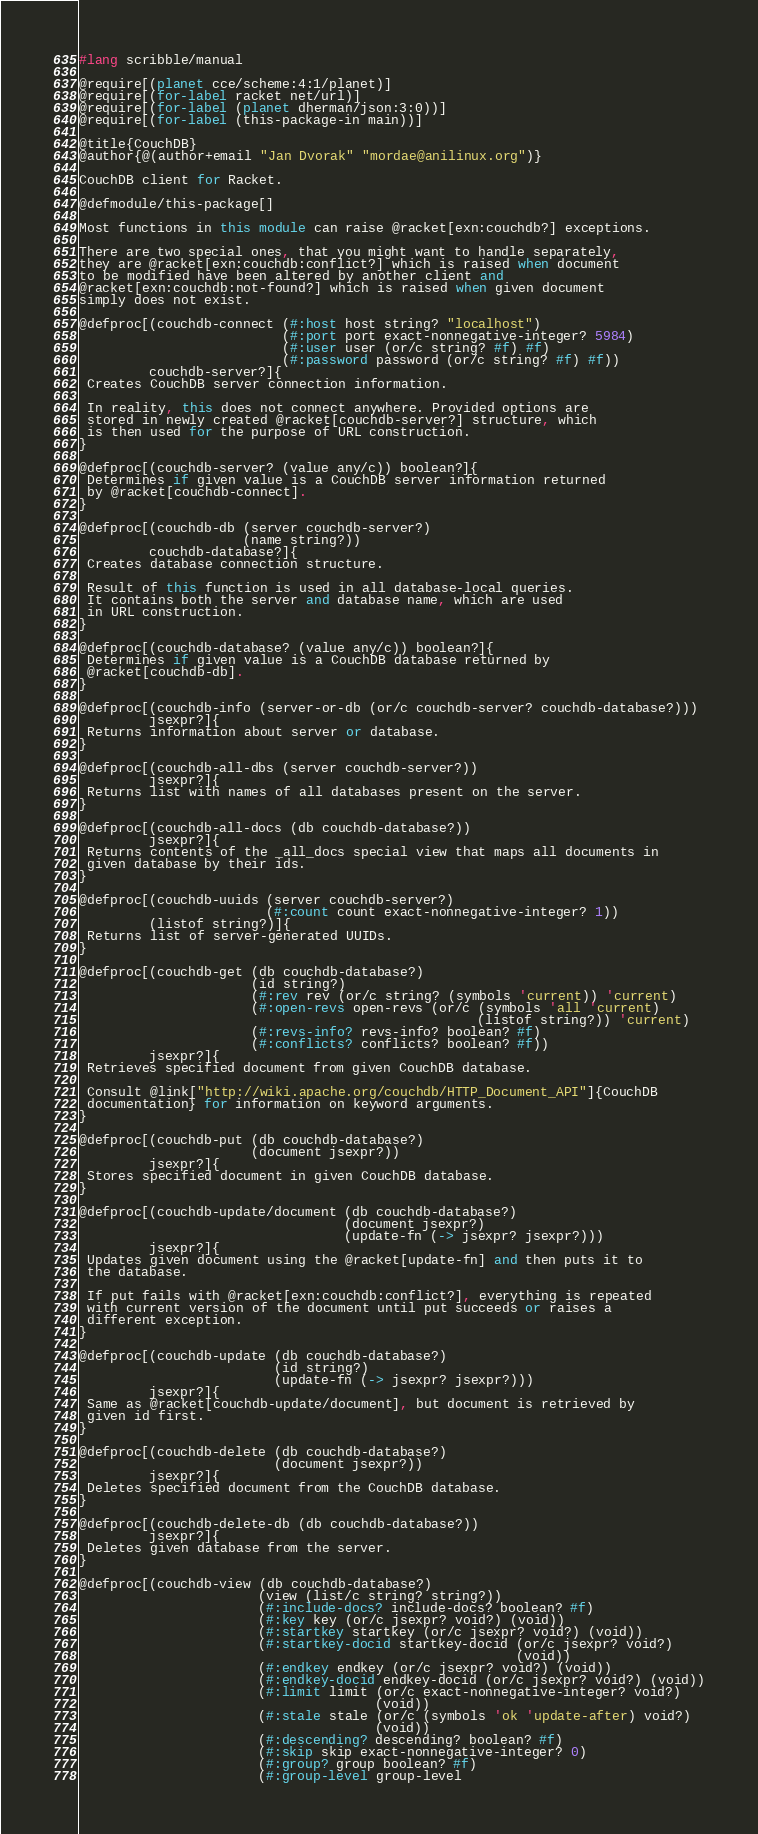Convert code to text. <code><loc_0><loc_0><loc_500><loc_500><_Racket_>#lang scribble/manual

@require[(planet cce/scheme:4:1/planet)]
@require[(for-label racket net/url)]
@require[(for-label (planet dherman/json:3:0))]
@require[(for-label (this-package-in main))]

@title{CouchDB}
@author{@(author+email "Jan Dvorak" "mordae@anilinux.org")}

CouchDB client for Racket.

@defmodule/this-package[]

Most functions in this module can raise @racket[exn:couchdb?] exceptions.

There are two special ones, that you might want to handle separately,
they are @racket[exn:couchdb:conflict?] which is raised when document
to be modified have been altered by another client and
@racket[exn:couchdb:not-found?] which is raised when given document
simply does not exist.

@defproc[(couchdb-connect (#:host host string? "localhost")
                          (#:port port exact-nonnegative-integer? 5984)
                          (#:user user (or/c string? #f) #f)
                          (#:password password (or/c string? #f) #f))
         couchdb-server?]{
 Creates CouchDB server connection information.

 In reality, this does not connect anywhere. Provided options are
 stored in newly created @racket[couchdb-server?] structure, which
 is then used for the purpose of URL construction.
}

@defproc[(couchdb-server? (value any/c)) boolean?]{
 Determines if given value is a CouchDB server information returned
 by @racket[couchdb-connect].
}

@defproc[(couchdb-db (server couchdb-server?)
                     (name string?))
         couchdb-database?]{
 Creates database connection structure.

 Result of this function is used in all database-local queries.
 It contains both the server and database name, which are used
 in URL construction.
}

@defproc[(couchdb-database? (value any/c)) boolean?]{
 Determines if given value is a CouchDB database returned by
 @racket[couchdb-db].
}

@defproc[(couchdb-info (server-or-db (or/c couchdb-server? couchdb-database?)))
         jsexpr?]{
 Returns information about server or database.
}

@defproc[(couchdb-all-dbs (server couchdb-server?))
         jsexpr?]{
 Returns list with names of all databases present on the server.
}

@defproc[(couchdb-all-docs (db couchdb-database?))
         jsexpr?]{
 Returns contents of the _all_docs special view that maps all documents in
 given database by their ids.
}

@defproc[(couchdb-uuids (server couchdb-server?)
                        (#:count count exact-nonnegative-integer? 1))
         (listof string?)]{
 Returns list of server-generated UUIDs.
}

@defproc[(couchdb-get (db couchdb-database?)
                      (id string?)
                      (#:rev rev (or/c string? (symbols 'current)) 'current)
                      (#:open-revs open-revs (or/c (symbols 'all 'current)
                                                   (listof string?)) 'current)
                      (#:revs-info? revs-info? boolean? #f)
                      (#:conflicts? conflicts? boolean? #f))
         jsexpr?]{
 Retrieves specified document from given CouchDB database.

 Consult @link["http://wiki.apache.org/couchdb/HTTP_Document_API"]{CouchDB
 documentation} for information on keyword arguments.
}

@defproc[(couchdb-put (db couchdb-database?)
                      (document jsexpr?))
         jsexpr?]{
 Stores specified document in given CouchDB database.
}

@defproc[(couchdb-update/document (db couchdb-database?)
                                  (document jsexpr?)
                                  (update-fn (-> jsexpr? jsexpr?)))
         jsexpr?]{
 Updates given document using the @racket[update-fn] and then puts it to
 the database.

 If put fails with @racket[exn:couchdb:conflict?], everything is repeated
 with current version of the document until put succeeds or raises a
 different exception.
}

@defproc[(couchdb-update (db couchdb-database?)
                         (id string?)
                         (update-fn (-> jsexpr? jsexpr?)))
         jsexpr?]{
 Same as @racket[couchdb-update/document], but document is retrieved by
 given id first.
}

@defproc[(couchdb-delete (db couchdb-database?)
                         (document jsexpr?))
         jsexpr?]{
 Deletes specified document from the CouchDB database.
}

@defproc[(couchdb-delete-db (db couchdb-database?))
         jsexpr?]{
 Deletes given database from the server.
}

@defproc[(couchdb-view (db couchdb-database?)
                       (view (list/c string? string?))
                       (#:include-docs? include-docs? boolean? #f)
                       (#:key key (or/c jsexpr? void?) (void))
                       (#:startkey startkey (or/c jsexpr? void?) (void))
                       (#:startkey-docid startkey-docid (or/c jsexpr? void?)
                                                        (void))
                       (#:endkey endkey (or/c jsexpr? void?) (void))
                       (#:endkey-docid endkey-docid (or/c jsexpr? void?) (void))
                       (#:limit limit (or/c exact-nonnegative-integer? void?)
                                      (void))
                       (#:stale stale (or/c (symbols 'ok 'update-after) void?)
                                      (void))
                       (#:descending? descending? boolean? #f)
                       (#:skip skip exact-nonnegative-integer? 0)
                       (#:group? group boolean? #f)
                       (#:group-level group-level</code> 